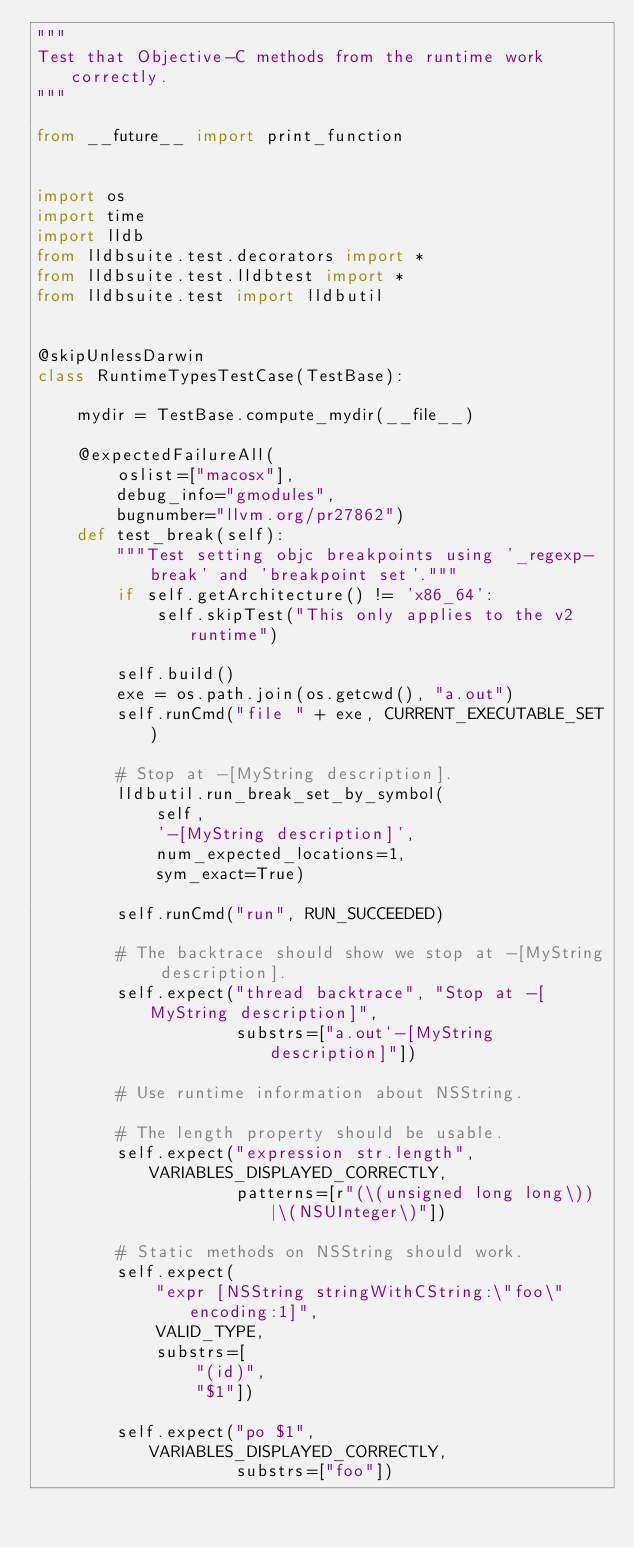<code> <loc_0><loc_0><loc_500><loc_500><_Python_>"""
Test that Objective-C methods from the runtime work correctly.
"""

from __future__ import print_function


import os
import time
import lldb
from lldbsuite.test.decorators import *
from lldbsuite.test.lldbtest import *
from lldbsuite.test import lldbutil


@skipUnlessDarwin
class RuntimeTypesTestCase(TestBase):

    mydir = TestBase.compute_mydir(__file__)

    @expectedFailureAll(
        oslist=["macosx"],
        debug_info="gmodules",
        bugnumber="llvm.org/pr27862")
    def test_break(self):
        """Test setting objc breakpoints using '_regexp-break' and 'breakpoint set'."""
        if self.getArchitecture() != 'x86_64':
            self.skipTest("This only applies to the v2 runtime")

        self.build()
        exe = os.path.join(os.getcwd(), "a.out")
        self.runCmd("file " + exe, CURRENT_EXECUTABLE_SET)

        # Stop at -[MyString description].
        lldbutil.run_break_set_by_symbol(
            self,
            '-[MyString description]',
            num_expected_locations=1,
            sym_exact=True)

        self.runCmd("run", RUN_SUCCEEDED)

        # The backtrace should show we stop at -[MyString description].
        self.expect("thread backtrace", "Stop at -[MyString description]",
                    substrs=["a.out`-[MyString description]"])

        # Use runtime information about NSString.

        # The length property should be usable.
        self.expect("expression str.length", VARIABLES_DISPLAYED_CORRECTLY,
                    patterns=[r"(\(unsigned long long\))|\(NSUInteger\)"])

        # Static methods on NSString should work.
        self.expect(
            "expr [NSString stringWithCString:\"foo\" encoding:1]",
            VALID_TYPE,
            substrs=[
                "(id)",
                "$1"])

        self.expect("po $1", VARIABLES_DISPLAYED_CORRECTLY,
                    substrs=["foo"])
</code> 